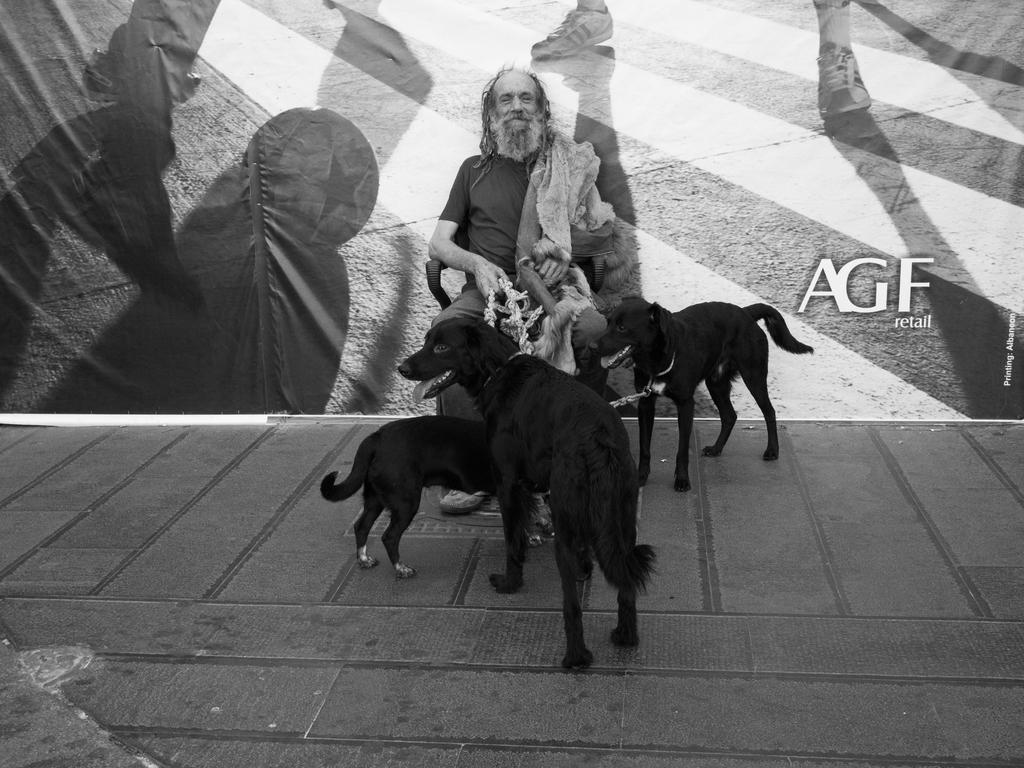How many dogs are in the image? There are three dogs in the image. What is the position of the dogs in relation to the person? The dogs are in front of the person. What is the person doing in the image? The person is sitting on a chair. What is behind the person in the image? There is a wall behind the person. What is written on the wall? The word "retail" is written on the wall. What type of advertisement is the person holding in the image? There is no advertisement present in the image; the person is sitting on a chair with dogs in front of them, and the wall behind them has the word "retail" written on it. 